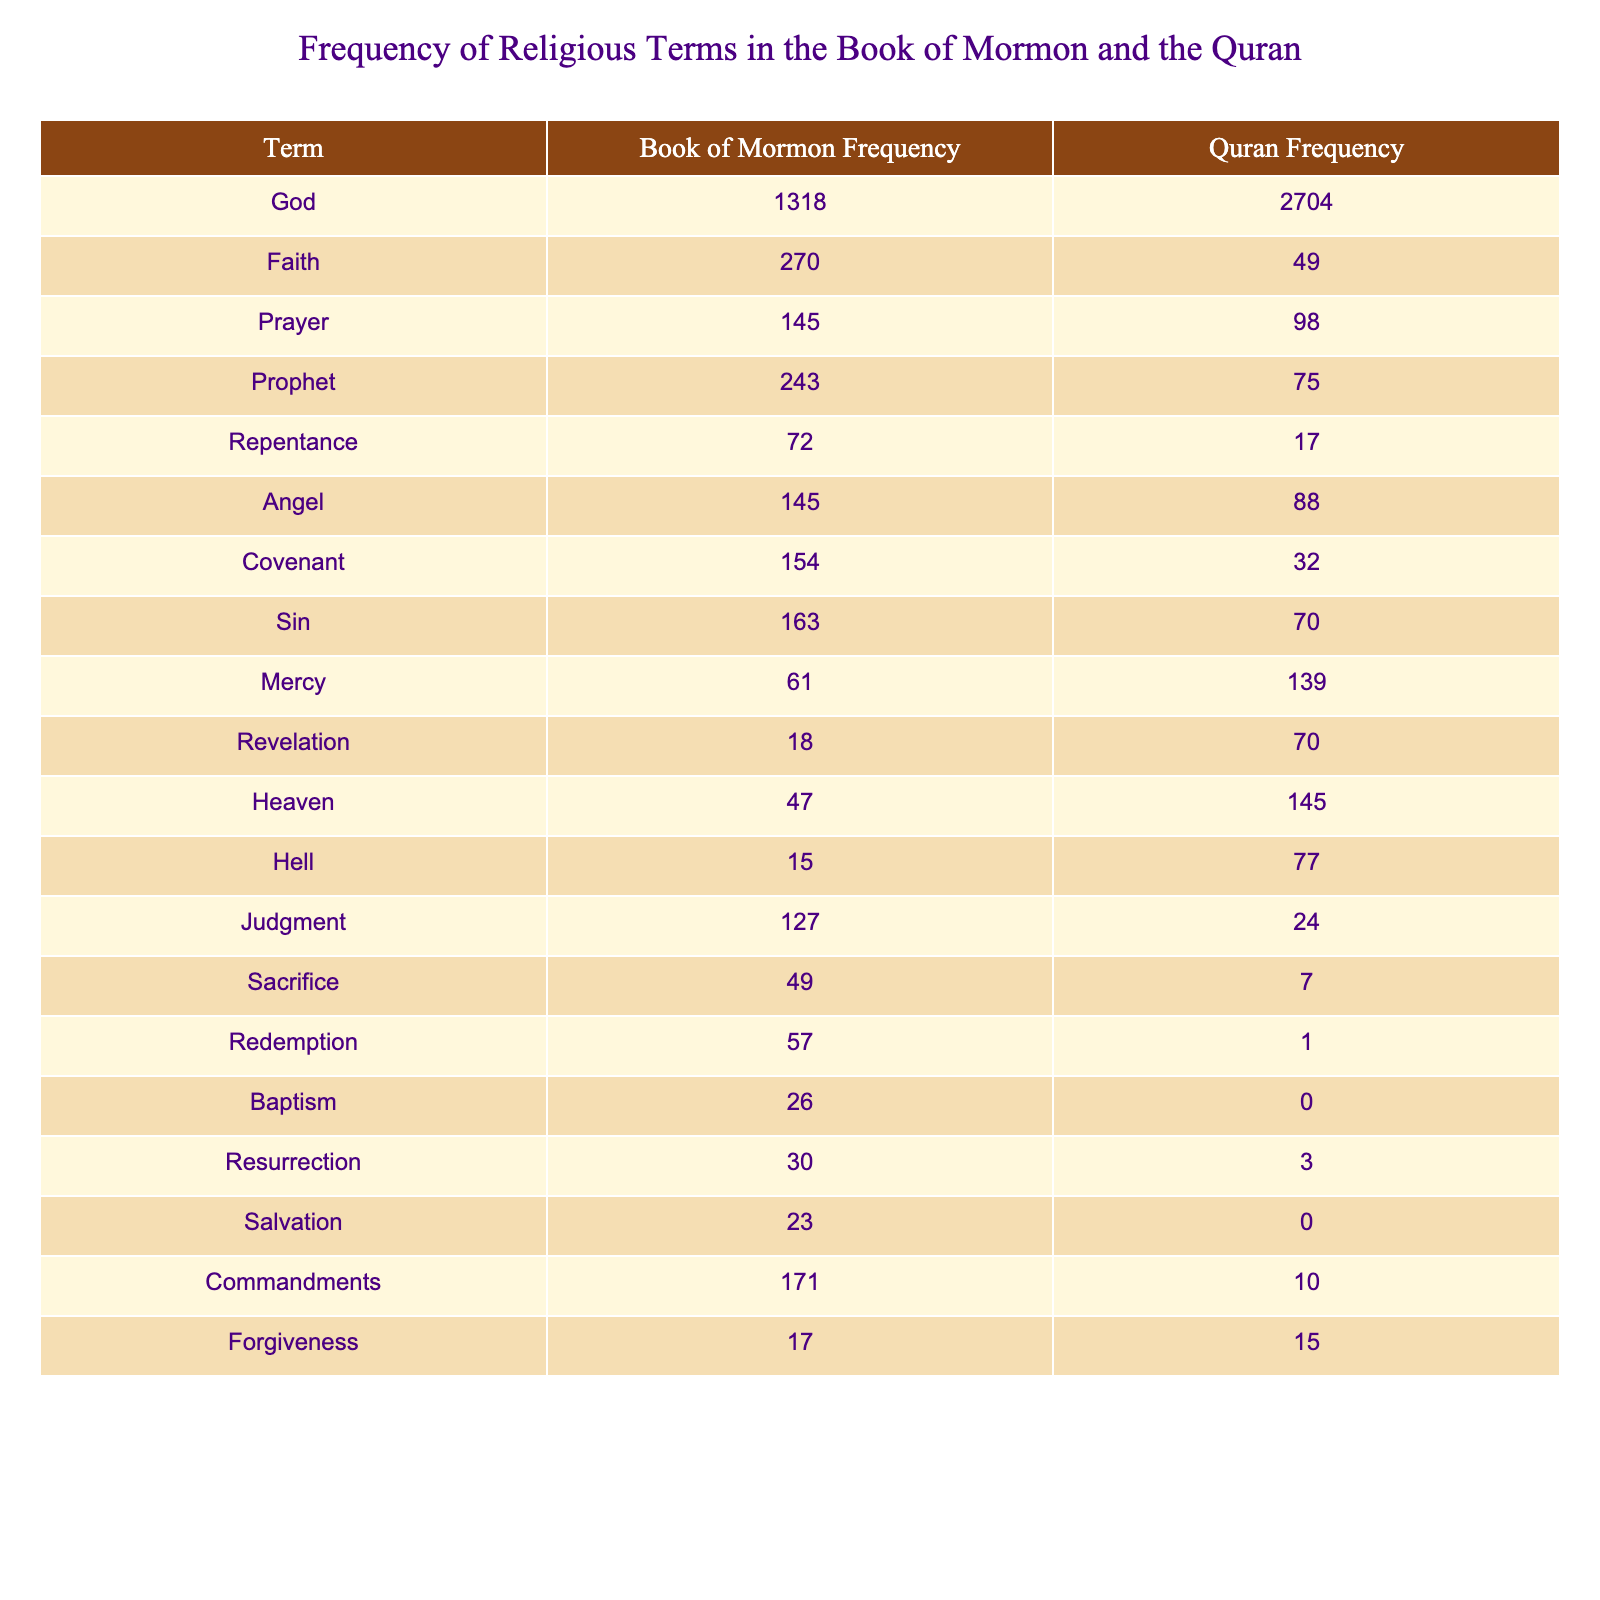What is the frequency of the term "God" in the Book of Mormon? According to the table, the frequency of the term "God" in the Book of Mormon is listed as 1318.
Answer: 1318 Which term appears most frequently in the Quran? The term "God" appears 2704 times in the Quran, which is the highest frequency recorded in the table.
Answer: God How many more times does the term "Faith" appear in the Book of Mormon compared to the Quran? The frequency of "Faith" in the Book of Mormon is 270, and in the Quran, it is 49. The difference is 270 - 49 = 221.
Answer: 221 Is the frequency of "Baptism" in the Quran greater than that in the Book of Mormon? The frequency of "Baptism" in the Quran is 0, while in the Book of Mormon it is 26. Thus, the frequency in the Quran is not greater.
Answer: No What is the average frequency of the religious terms in the Book of Mormon? To find the average, sum the frequencies for the Book of Mormon: 1318 + 270 + 145 + 243 + 72 + 145 + 154 + 163 + 61 + 18 + 47 + 15 + 49 + 57 + 26 + 30 + 23 + 171 + 17 = 2367. There are 18 terms, so the average is 2367 / 18 = 131.5.
Answer: 131.5 Which term has the highest frequency in both the Book of Mormon and the Quran? In the table, "God" shows the highest frequency in both texts: 1318 in the Book of Mormon and 2704 in the Quran.
Answer: God How many terms have a higher frequency in the Quran than the Book of Mormon? By examining the table, the terms "God," "Mercy," "Heaven," "Hell," and "Judgment" have higher frequencies in the Quran than in the Book of Mormon, totaling 5 terms.
Answer: 5 What is the difference between the frequency of "Angel" in the Book of Mormon and its frequency in the Quran? The frequency of "Angel" in the Book of Mormon is 145, and in the Quran, it is 88. Thus, the difference is 145 - 88 = 57.
Answer: 57 Which term has the least frequency in the Quran? From the table, "Baptism" has a frequency of 0 in the Quran, which is the least among all listed terms.
Answer: Baptism Which term saw a greater emphasis in the Book of Mormon with a frequency of 171 compared to the Quran's frequency? The term that has a frequency of 171 in the Book of Mormon is "Commandments," while its frequency in the Quran is only 10. This highlights a significant emphasis in the Book of Mormon.
Answer: Commandments 